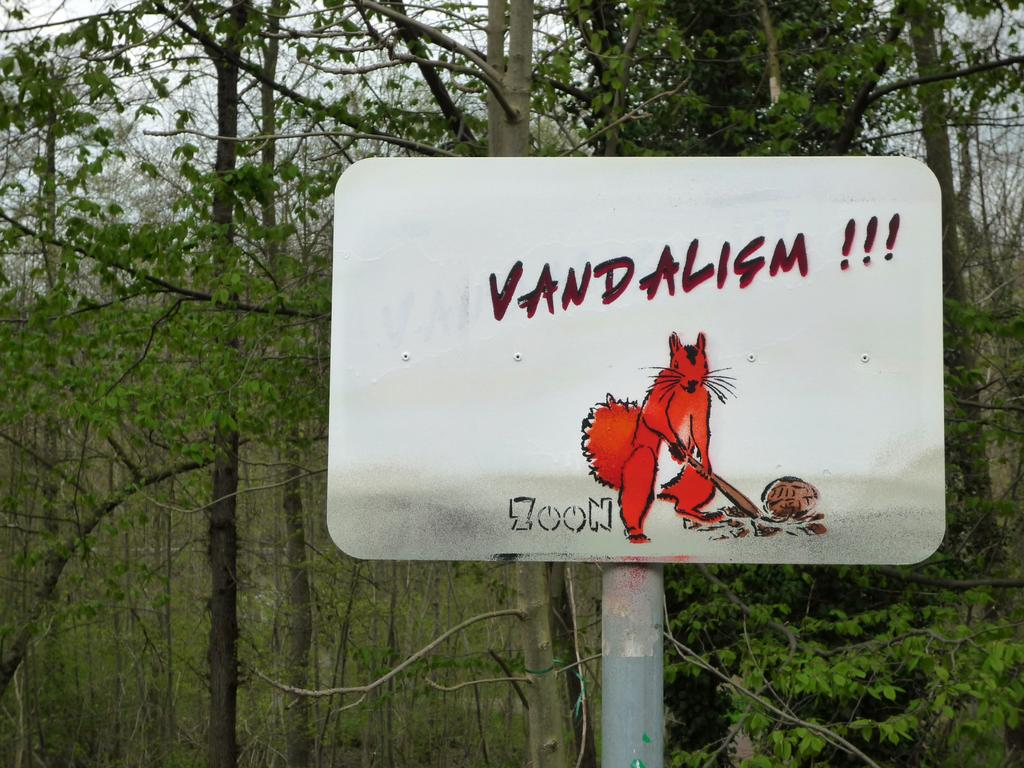What is on the pole that is visible in the image? There is a board on a pole in the image. What can be seen in the background of the image? There are trees and the sky visible in the background of the image. What type of breath can be seen coming from the trees in the image? There is no breath visible in the image, as trees do not have the ability to breathe. 